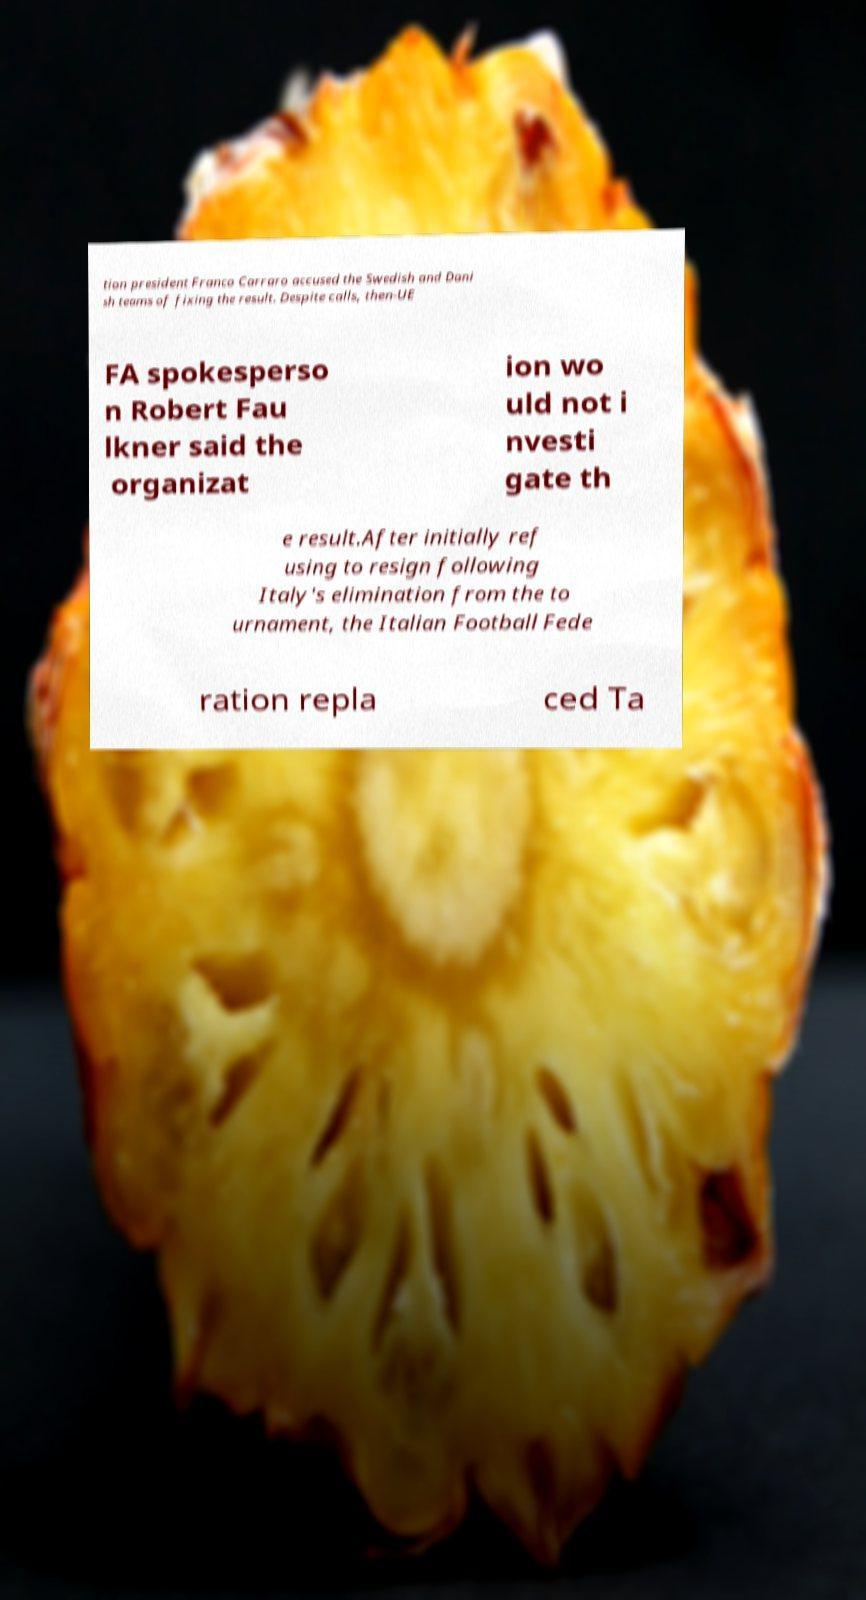What messages or text are displayed in this image? I need them in a readable, typed format. tion president Franco Carraro accused the Swedish and Dani sh teams of fixing the result. Despite calls, then-UE FA spokesperso n Robert Fau lkner said the organizat ion wo uld not i nvesti gate th e result.After initially ref using to resign following Italy's elimination from the to urnament, the Italian Football Fede ration repla ced Ta 